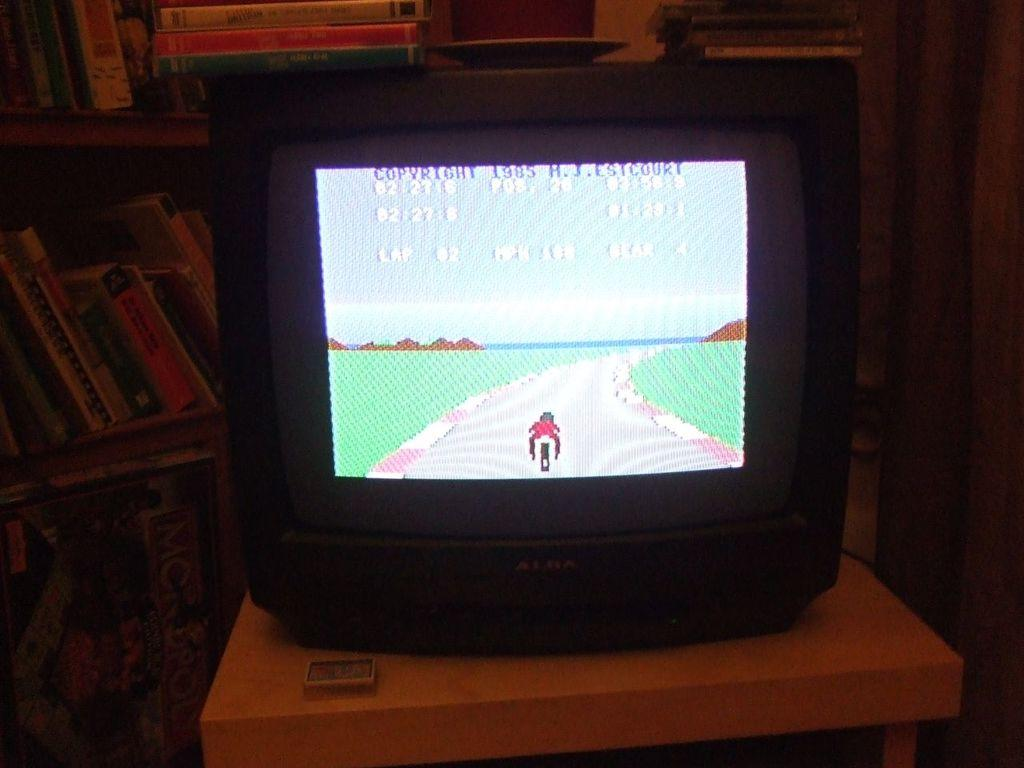<image>
Offer a succinct explanation of the picture presented. The copyright for the video game on the television screen is from 1985. 